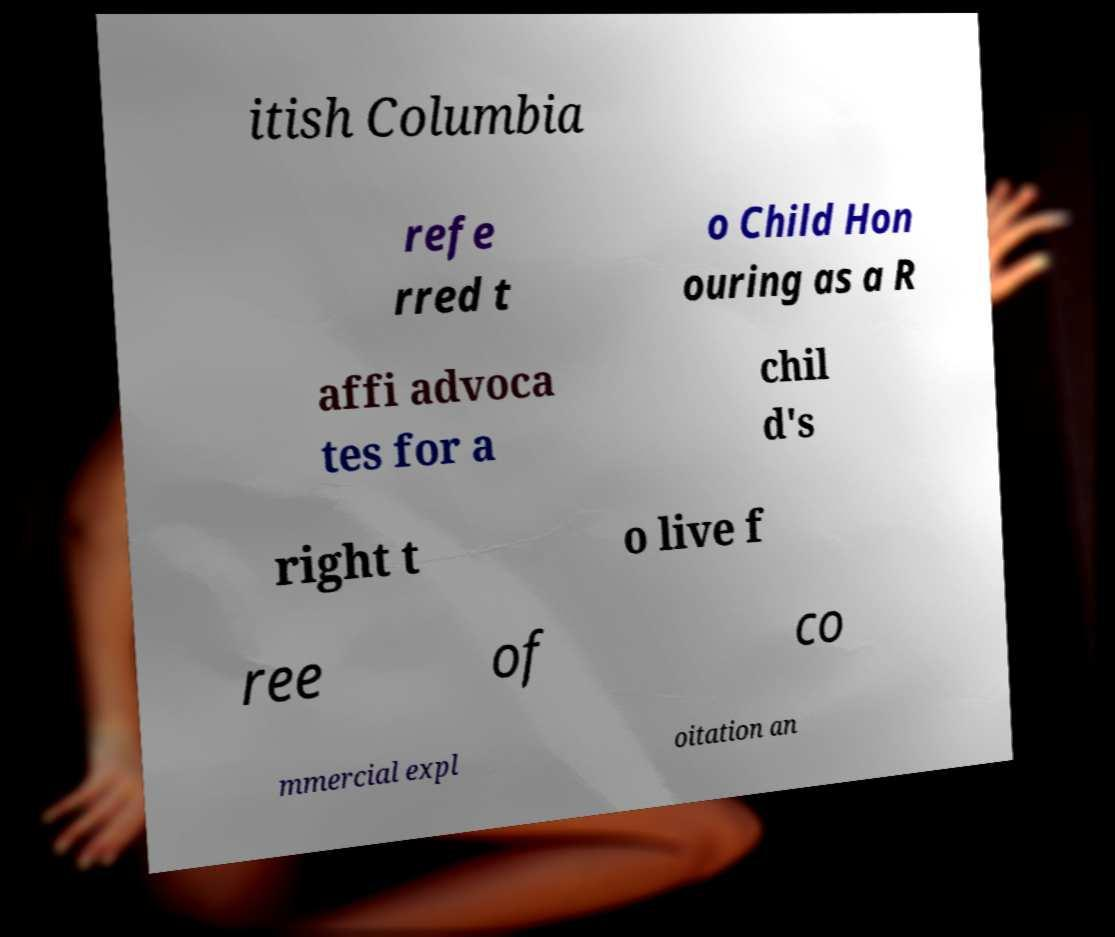Could you extract and type out the text from this image? itish Columbia refe rred t o Child Hon ouring as a R affi advoca tes for a chil d's right t o live f ree of co mmercial expl oitation an 